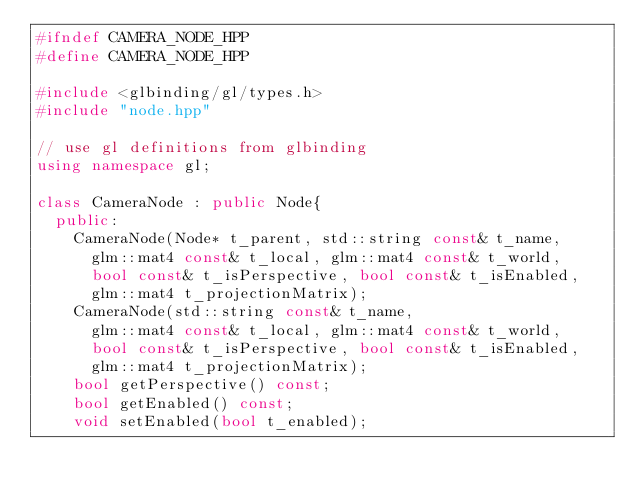Convert code to text. <code><loc_0><loc_0><loc_500><loc_500><_C++_>#ifndef CAMERA_NODE_HPP
#define CAMERA_NODE_HPP

#include <glbinding/gl/types.h>
#include "node.hpp"

// use gl definitions from glbinding 
using namespace gl;

class CameraNode : public Node{
	public:
		CameraNode(Node* t_parent, std::string const& t_name,
			glm::mat4 const& t_local, glm::mat4 const& t_world, 
			bool const& t_isPerspective, bool const& t_isEnabled,
			glm::mat4 t_projectionMatrix);
		CameraNode(std::string const& t_name,
			glm::mat4 const& t_local, glm::mat4 const& t_world, 
			bool const& t_isPerspective, bool const& t_isEnabled,
			glm::mat4 t_projectionMatrix);
		bool getPerspective() const;
		bool getEnabled() const;
		void setEnabled(bool t_enabled);</code> 